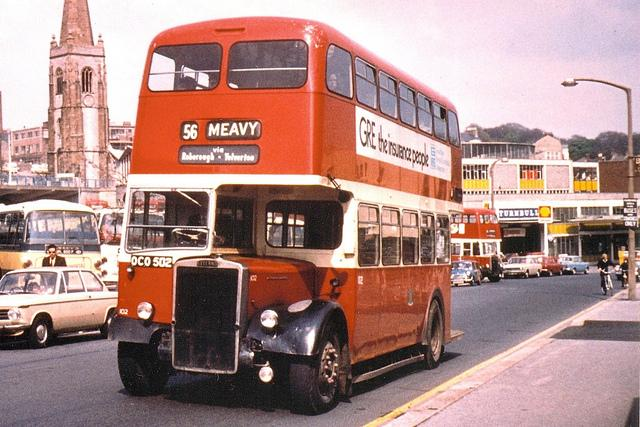Why does the vehicle have two levels? Please explain your reasoning. for sightseeing. So that passengers can be able to view various sites. 